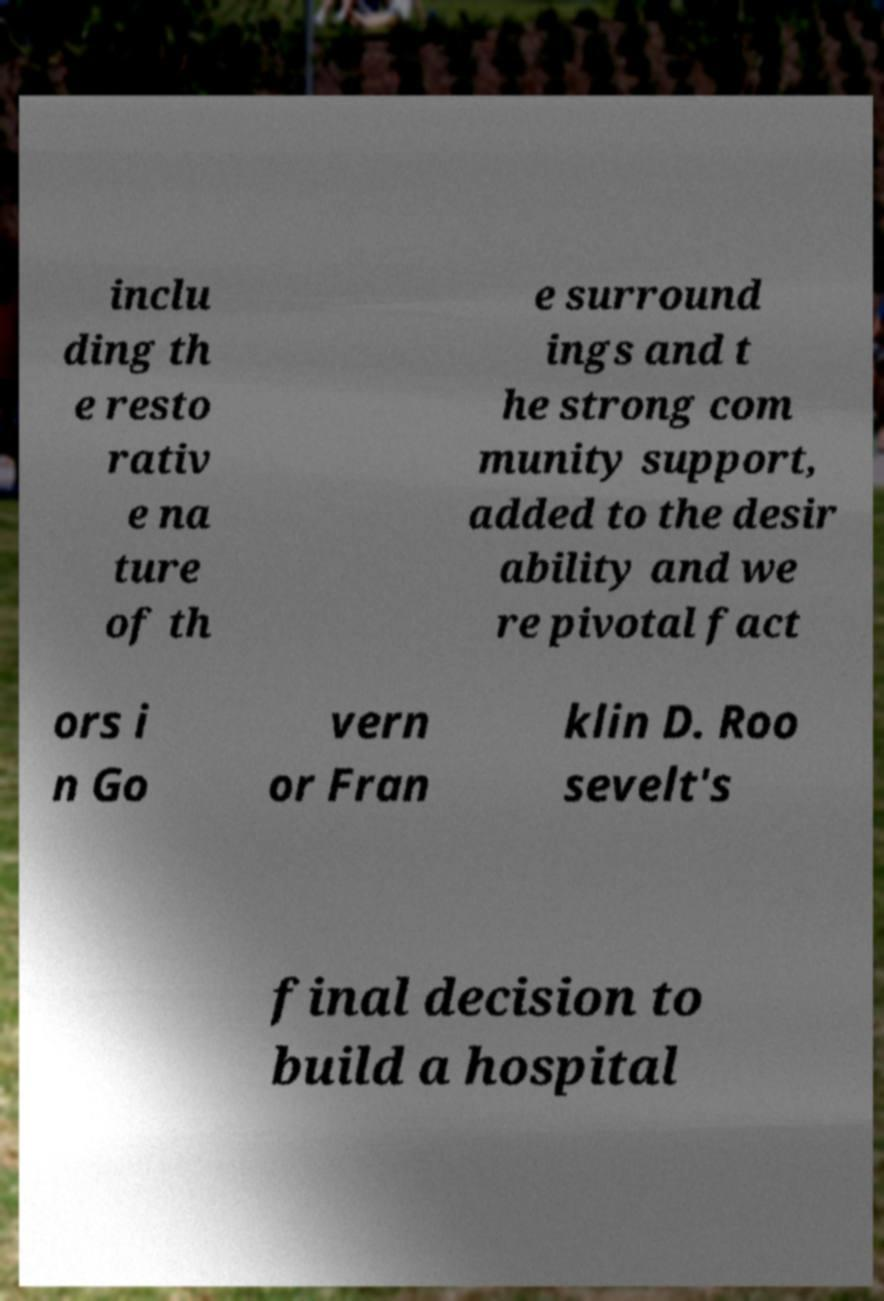Can you accurately transcribe the text from the provided image for me? inclu ding th e resto rativ e na ture of th e surround ings and t he strong com munity support, added to the desir ability and we re pivotal fact ors i n Go vern or Fran klin D. Roo sevelt's final decision to build a hospital 